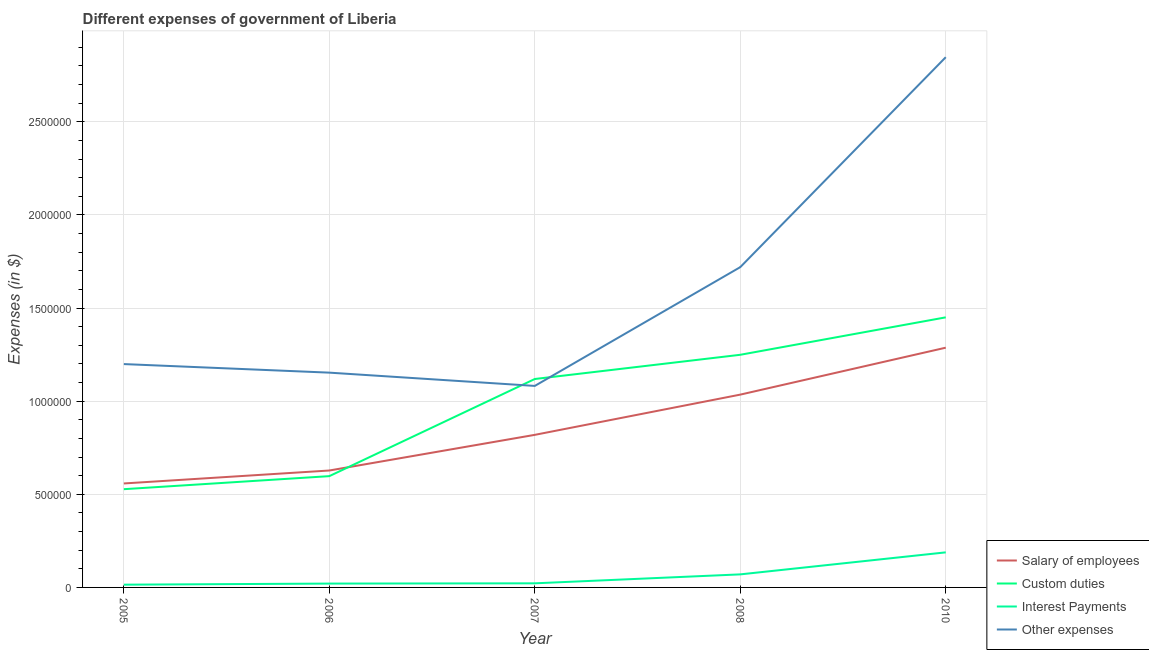Does the line corresponding to amount spent on custom duties intersect with the line corresponding to amount spent on other expenses?
Make the answer very short. Yes. Is the number of lines equal to the number of legend labels?
Offer a very short reply. Yes. What is the amount spent on interest payments in 2006?
Make the answer very short. 2.07e+04. Across all years, what is the maximum amount spent on custom duties?
Offer a very short reply. 1.45e+06. Across all years, what is the minimum amount spent on other expenses?
Offer a very short reply. 1.08e+06. In which year was the amount spent on custom duties maximum?
Make the answer very short. 2010. What is the total amount spent on interest payments in the graph?
Your answer should be compact. 3.16e+05. What is the difference between the amount spent on custom duties in 2005 and that in 2006?
Offer a terse response. -7.00e+04. What is the difference between the amount spent on salary of employees in 2006 and the amount spent on other expenses in 2005?
Give a very brief answer. -5.72e+05. What is the average amount spent on interest payments per year?
Your answer should be compact. 6.32e+04. In the year 2007, what is the difference between the amount spent on salary of employees and amount spent on custom duties?
Your answer should be very brief. -3.00e+05. In how many years, is the amount spent on other expenses greater than 1100000 $?
Provide a succinct answer. 4. What is the ratio of the amount spent on other expenses in 2005 to that in 2008?
Your response must be concise. 0.7. Is the amount spent on salary of employees in 2005 less than that in 2010?
Provide a succinct answer. Yes. Is the difference between the amount spent on salary of employees in 2005 and 2006 greater than the difference between the amount spent on interest payments in 2005 and 2006?
Ensure brevity in your answer.  No. What is the difference between the highest and the second highest amount spent on other expenses?
Make the answer very short. 1.13e+06. What is the difference between the highest and the lowest amount spent on other expenses?
Your answer should be very brief. 1.77e+06. In how many years, is the amount spent on other expenses greater than the average amount spent on other expenses taken over all years?
Make the answer very short. 2. Is the sum of the amount spent on other expenses in 2008 and 2010 greater than the maximum amount spent on salary of employees across all years?
Your answer should be very brief. Yes. Is it the case that in every year, the sum of the amount spent on other expenses and amount spent on salary of employees is greater than the sum of amount spent on interest payments and amount spent on custom duties?
Your answer should be compact. Yes. Is the amount spent on salary of employees strictly greater than the amount spent on other expenses over the years?
Offer a very short reply. No. Is the amount spent on salary of employees strictly less than the amount spent on interest payments over the years?
Your answer should be compact. No. How many lines are there?
Ensure brevity in your answer.  4. How many years are there in the graph?
Your answer should be very brief. 5. What is the difference between two consecutive major ticks on the Y-axis?
Provide a succinct answer. 5.00e+05. Does the graph contain grids?
Give a very brief answer. Yes. What is the title of the graph?
Provide a short and direct response. Different expenses of government of Liberia. What is the label or title of the Y-axis?
Your answer should be very brief. Expenses (in $). What is the Expenses (in $) in Salary of employees in 2005?
Your answer should be very brief. 5.58e+05. What is the Expenses (in $) of Custom duties in 2005?
Provide a succinct answer. 5.28e+05. What is the Expenses (in $) of Interest Payments in 2005?
Make the answer very short. 1.48e+04. What is the Expenses (in $) of Other expenses in 2005?
Ensure brevity in your answer.  1.20e+06. What is the Expenses (in $) in Salary of employees in 2006?
Offer a very short reply. 6.28e+05. What is the Expenses (in $) of Custom duties in 2006?
Provide a short and direct response. 5.98e+05. What is the Expenses (in $) in Interest Payments in 2006?
Your answer should be very brief. 2.07e+04. What is the Expenses (in $) of Other expenses in 2006?
Your answer should be compact. 1.15e+06. What is the Expenses (in $) in Salary of employees in 2007?
Your answer should be very brief. 8.19e+05. What is the Expenses (in $) in Custom duties in 2007?
Your answer should be very brief. 1.12e+06. What is the Expenses (in $) in Interest Payments in 2007?
Offer a terse response. 2.20e+04. What is the Expenses (in $) in Other expenses in 2007?
Provide a succinct answer. 1.08e+06. What is the Expenses (in $) of Salary of employees in 2008?
Your answer should be compact. 1.04e+06. What is the Expenses (in $) in Custom duties in 2008?
Make the answer very short. 1.25e+06. What is the Expenses (in $) in Interest Payments in 2008?
Provide a short and direct response. 7.01e+04. What is the Expenses (in $) of Other expenses in 2008?
Your answer should be compact. 1.72e+06. What is the Expenses (in $) in Salary of employees in 2010?
Give a very brief answer. 1.29e+06. What is the Expenses (in $) of Custom duties in 2010?
Keep it short and to the point. 1.45e+06. What is the Expenses (in $) in Interest Payments in 2010?
Give a very brief answer. 1.88e+05. What is the Expenses (in $) of Other expenses in 2010?
Provide a succinct answer. 2.85e+06. Across all years, what is the maximum Expenses (in $) in Salary of employees?
Your answer should be compact. 1.29e+06. Across all years, what is the maximum Expenses (in $) in Custom duties?
Make the answer very short. 1.45e+06. Across all years, what is the maximum Expenses (in $) of Interest Payments?
Make the answer very short. 1.88e+05. Across all years, what is the maximum Expenses (in $) in Other expenses?
Ensure brevity in your answer.  2.85e+06. Across all years, what is the minimum Expenses (in $) of Salary of employees?
Your response must be concise. 5.58e+05. Across all years, what is the minimum Expenses (in $) of Custom duties?
Your answer should be compact. 5.28e+05. Across all years, what is the minimum Expenses (in $) of Interest Payments?
Your answer should be compact. 1.48e+04. Across all years, what is the minimum Expenses (in $) in Other expenses?
Ensure brevity in your answer.  1.08e+06. What is the total Expenses (in $) in Salary of employees in the graph?
Provide a short and direct response. 4.33e+06. What is the total Expenses (in $) of Custom duties in the graph?
Give a very brief answer. 4.94e+06. What is the total Expenses (in $) in Interest Payments in the graph?
Give a very brief answer. 3.16e+05. What is the total Expenses (in $) of Other expenses in the graph?
Give a very brief answer. 8.00e+06. What is the difference between the Expenses (in $) in Salary of employees in 2005 and that in 2006?
Offer a terse response. -6.96e+04. What is the difference between the Expenses (in $) in Custom duties in 2005 and that in 2006?
Provide a succinct answer. -7.00e+04. What is the difference between the Expenses (in $) of Interest Payments in 2005 and that in 2006?
Offer a very short reply. -5850.55. What is the difference between the Expenses (in $) of Other expenses in 2005 and that in 2006?
Your answer should be compact. 4.60e+04. What is the difference between the Expenses (in $) of Salary of employees in 2005 and that in 2007?
Make the answer very short. -2.61e+05. What is the difference between the Expenses (in $) of Custom duties in 2005 and that in 2007?
Provide a succinct answer. -5.92e+05. What is the difference between the Expenses (in $) in Interest Payments in 2005 and that in 2007?
Ensure brevity in your answer.  -7224.07. What is the difference between the Expenses (in $) of Other expenses in 2005 and that in 2007?
Your response must be concise. 1.17e+05. What is the difference between the Expenses (in $) in Salary of employees in 2005 and that in 2008?
Make the answer very short. -4.77e+05. What is the difference between the Expenses (in $) of Custom duties in 2005 and that in 2008?
Provide a succinct answer. -7.22e+05. What is the difference between the Expenses (in $) of Interest Payments in 2005 and that in 2008?
Keep it short and to the point. -5.53e+04. What is the difference between the Expenses (in $) in Other expenses in 2005 and that in 2008?
Keep it short and to the point. -5.21e+05. What is the difference between the Expenses (in $) in Salary of employees in 2005 and that in 2010?
Your answer should be very brief. -7.29e+05. What is the difference between the Expenses (in $) of Custom duties in 2005 and that in 2010?
Make the answer very short. -9.23e+05. What is the difference between the Expenses (in $) in Interest Payments in 2005 and that in 2010?
Keep it short and to the point. -1.73e+05. What is the difference between the Expenses (in $) in Other expenses in 2005 and that in 2010?
Provide a short and direct response. -1.65e+06. What is the difference between the Expenses (in $) of Salary of employees in 2006 and that in 2007?
Offer a very short reply. -1.91e+05. What is the difference between the Expenses (in $) in Custom duties in 2006 and that in 2007?
Provide a short and direct response. -5.22e+05. What is the difference between the Expenses (in $) in Interest Payments in 2006 and that in 2007?
Provide a short and direct response. -1373.52. What is the difference between the Expenses (in $) in Other expenses in 2006 and that in 2007?
Keep it short and to the point. 7.13e+04. What is the difference between the Expenses (in $) in Salary of employees in 2006 and that in 2008?
Your answer should be compact. -4.08e+05. What is the difference between the Expenses (in $) of Custom duties in 2006 and that in 2008?
Your answer should be very brief. -6.52e+05. What is the difference between the Expenses (in $) of Interest Payments in 2006 and that in 2008?
Your answer should be very brief. -4.94e+04. What is the difference between the Expenses (in $) in Other expenses in 2006 and that in 2008?
Your answer should be very brief. -5.67e+05. What is the difference between the Expenses (in $) in Salary of employees in 2006 and that in 2010?
Offer a terse response. -6.60e+05. What is the difference between the Expenses (in $) in Custom duties in 2006 and that in 2010?
Your answer should be very brief. -8.53e+05. What is the difference between the Expenses (in $) in Interest Payments in 2006 and that in 2010?
Your answer should be compact. -1.68e+05. What is the difference between the Expenses (in $) in Other expenses in 2006 and that in 2010?
Your answer should be very brief. -1.69e+06. What is the difference between the Expenses (in $) in Salary of employees in 2007 and that in 2008?
Your answer should be very brief. -2.16e+05. What is the difference between the Expenses (in $) in Custom duties in 2007 and that in 2008?
Give a very brief answer. -1.30e+05. What is the difference between the Expenses (in $) in Interest Payments in 2007 and that in 2008?
Offer a very short reply. -4.80e+04. What is the difference between the Expenses (in $) in Other expenses in 2007 and that in 2008?
Ensure brevity in your answer.  -6.38e+05. What is the difference between the Expenses (in $) of Salary of employees in 2007 and that in 2010?
Offer a very short reply. -4.68e+05. What is the difference between the Expenses (in $) of Custom duties in 2007 and that in 2010?
Make the answer very short. -3.31e+05. What is the difference between the Expenses (in $) of Interest Payments in 2007 and that in 2010?
Your answer should be compact. -1.66e+05. What is the difference between the Expenses (in $) of Other expenses in 2007 and that in 2010?
Keep it short and to the point. -1.77e+06. What is the difference between the Expenses (in $) of Salary of employees in 2008 and that in 2010?
Ensure brevity in your answer.  -2.52e+05. What is the difference between the Expenses (in $) in Custom duties in 2008 and that in 2010?
Give a very brief answer. -2.01e+05. What is the difference between the Expenses (in $) of Interest Payments in 2008 and that in 2010?
Ensure brevity in your answer.  -1.18e+05. What is the difference between the Expenses (in $) of Other expenses in 2008 and that in 2010?
Provide a succinct answer. -1.13e+06. What is the difference between the Expenses (in $) in Salary of employees in 2005 and the Expenses (in $) in Custom duties in 2006?
Ensure brevity in your answer.  -3.93e+04. What is the difference between the Expenses (in $) of Salary of employees in 2005 and the Expenses (in $) of Interest Payments in 2006?
Make the answer very short. 5.38e+05. What is the difference between the Expenses (in $) in Salary of employees in 2005 and the Expenses (in $) in Other expenses in 2006?
Provide a succinct answer. -5.95e+05. What is the difference between the Expenses (in $) in Custom duties in 2005 and the Expenses (in $) in Interest Payments in 2006?
Provide a short and direct response. 5.07e+05. What is the difference between the Expenses (in $) of Custom duties in 2005 and the Expenses (in $) of Other expenses in 2006?
Provide a succinct answer. -6.26e+05. What is the difference between the Expenses (in $) in Interest Payments in 2005 and the Expenses (in $) in Other expenses in 2006?
Your answer should be compact. -1.14e+06. What is the difference between the Expenses (in $) in Salary of employees in 2005 and the Expenses (in $) in Custom duties in 2007?
Give a very brief answer. -5.61e+05. What is the difference between the Expenses (in $) in Salary of employees in 2005 and the Expenses (in $) in Interest Payments in 2007?
Offer a terse response. 5.36e+05. What is the difference between the Expenses (in $) of Salary of employees in 2005 and the Expenses (in $) of Other expenses in 2007?
Make the answer very short. -5.24e+05. What is the difference between the Expenses (in $) of Custom duties in 2005 and the Expenses (in $) of Interest Payments in 2007?
Your response must be concise. 5.05e+05. What is the difference between the Expenses (in $) of Custom duties in 2005 and the Expenses (in $) of Other expenses in 2007?
Provide a short and direct response. -5.55e+05. What is the difference between the Expenses (in $) of Interest Payments in 2005 and the Expenses (in $) of Other expenses in 2007?
Make the answer very short. -1.07e+06. What is the difference between the Expenses (in $) in Salary of employees in 2005 and the Expenses (in $) in Custom duties in 2008?
Your response must be concise. -6.91e+05. What is the difference between the Expenses (in $) in Salary of employees in 2005 and the Expenses (in $) in Interest Payments in 2008?
Your answer should be very brief. 4.88e+05. What is the difference between the Expenses (in $) in Salary of employees in 2005 and the Expenses (in $) in Other expenses in 2008?
Provide a short and direct response. -1.16e+06. What is the difference between the Expenses (in $) in Custom duties in 2005 and the Expenses (in $) in Interest Payments in 2008?
Make the answer very short. 4.57e+05. What is the difference between the Expenses (in $) of Custom duties in 2005 and the Expenses (in $) of Other expenses in 2008?
Make the answer very short. -1.19e+06. What is the difference between the Expenses (in $) in Interest Payments in 2005 and the Expenses (in $) in Other expenses in 2008?
Your response must be concise. -1.71e+06. What is the difference between the Expenses (in $) of Salary of employees in 2005 and the Expenses (in $) of Custom duties in 2010?
Provide a short and direct response. -8.92e+05. What is the difference between the Expenses (in $) of Salary of employees in 2005 and the Expenses (in $) of Interest Payments in 2010?
Ensure brevity in your answer.  3.70e+05. What is the difference between the Expenses (in $) of Salary of employees in 2005 and the Expenses (in $) of Other expenses in 2010?
Provide a short and direct response. -2.29e+06. What is the difference between the Expenses (in $) in Custom duties in 2005 and the Expenses (in $) in Interest Payments in 2010?
Your answer should be very brief. 3.39e+05. What is the difference between the Expenses (in $) in Custom duties in 2005 and the Expenses (in $) in Other expenses in 2010?
Give a very brief answer. -2.32e+06. What is the difference between the Expenses (in $) of Interest Payments in 2005 and the Expenses (in $) of Other expenses in 2010?
Make the answer very short. -2.83e+06. What is the difference between the Expenses (in $) in Salary of employees in 2006 and the Expenses (in $) in Custom duties in 2007?
Make the answer very short. -4.91e+05. What is the difference between the Expenses (in $) in Salary of employees in 2006 and the Expenses (in $) in Interest Payments in 2007?
Offer a terse response. 6.06e+05. What is the difference between the Expenses (in $) of Salary of employees in 2006 and the Expenses (in $) of Other expenses in 2007?
Offer a very short reply. -4.54e+05. What is the difference between the Expenses (in $) of Custom duties in 2006 and the Expenses (in $) of Interest Payments in 2007?
Ensure brevity in your answer.  5.76e+05. What is the difference between the Expenses (in $) of Custom duties in 2006 and the Expenses (in $) of Other expenses in 2007?
Your answer should be very brief. -4.84e+05. What is the difference between the Expenses (in $) of Interest Payments in 2006 and the Expenses (in $) of Other expenses in 2007?
Provide a short and direct response. -1.06e+06. What is the difference between the Expenses (in $) of Salary of employees in 2006 and the Expenses (in $) of Custom duties in 2008?
Give a very brief answer. -6.21e+05. What is the difference between the Expenses (in $) of Salary of employees in 2006 and the Expenses (in $) of Interest Payments in 2008?
Provide a short and direct response. 5.58e+05. What is the difference between the Expenses (in $) of Salary of employees in 2006 and the Expenses (in $) of Other expenses in 2008?
Provide a short and direct response. -1.09e+06. What is the difference between the Expenses (in $) of Custom duties in 2006 and the Expenses (in $) of Interest Payments in 2008?
Offer a very short reply. 5.28e+05. What is the difference between the Expenses (in $) in Custom duties in 2006 and the Expenses (in $) in Other expenses in 2008?
Make the answer very short. -1.12e+06. What is the difference between the Expenses (in $) in Interest Payments in 2006 and the Expenses (in $) in Other expenses in 2008?
Give a very brief answer. -1.70e+06. What is the difference between the Expenses (in $) of Salary of employees in 2006 and the Expenses (in $) of Custom duties in 2010?
Ensure brevity in your answer.  -8.22e+05. What is the difference between the Expenses (in $) of Salary of employees in 2006 and the Expenses (in $) of Interest Payments in 2010?
Keep it short and to the point. 4.40e+05. What is the difference between the Expenses (in $) in Salary of employees in 2006 and the Expenses (in $) in Other expenses in 2010?
Your response must be concise. -2.22e+06. What is the difference between the Expenses (in $) in Custom duties in 2006 and the Expenses (in $) in Interest Payments in 2010?
Your answer should be compact. 4.09e+05. What is the difference between the Expenses (in $) of Custom duties in 2006 and the Expenses (in $) of Other expenses in 2010?
Your answer should be compact. -2.25e+06. What is the difference between the Expenses (in $) in Interest Payments in 2006 and the Expenses (in $) in Other expenses in 2010?
Give a very brief answer. -2.83e+06. What is the difference between the Expenses (in $) of Salary of employees in 2007 and the Expenses (in $) of Custom duties in 2008?
Provide a succinct answer. -4.30e+05. What is the difference between the Expenses (in $) in Salary of employees in 2007 and the Expenses (in $) in Interest Payments in 2008?
Ensure brevity in your answer.  7.49e+05. What is the difference between the Expenses (in $) of Salary of employees in 2007 and the Expenses (in $) of Other expenses in 2008?
Keep it short and to the point. -9.01e+05. What is the difference between the Expenses (in $) in Custom duties in 2007 and the Expenses (in $) in Interest Payments in 2008?
Offer a very short reply. 1.05e+06. What is the difference between the Expenses (in $) in Custom duties in 2007 and the Expenses (in $) in Other expenses in 2008?
Make the answer very short. -6.01e+05. What is the difference between the Expenses (in $) of Interest Payments in 2007 and the Expenses (in $) of Other expenses in 2008?
Offer a very short reply. -1.70e+06. What is the difference between the Expenses (in $) of Salary of employees in 2007 and the Expenses (in $) of Custom duties in 2010?
Your answer should be compact. -6.31e+05. What is the difference between the Expenses (in $) of Salary of employees in 2007 and the Expenses (in $) of Interest Payments in 2010?
Ensure brevity in your answer.  6.31e+05. What is the difference between the Expenses (in $) of Salary of employees in 2007 and the Expenses (in $) of Other expenses in 2010?
Keep it short and to the point. -2.03e+06. What is the difference between the Expenses (in $) of Custom duties in 2007 and the Expenses (in $) of Interest Payments in 2010?
Offer a very short reply. 9.31e+05. What is the difference between the Expenses (in $) in Custom duties in 2007 and the Expenses (in $) in Other expenses in 2010?
Your answer should be very brief. -1.73e+06. What is the difference between the Expenses (in $) of Interest Payments in 2007 and the Expenses (in $) of Other expenses in 2010?
Keep it short and to the point. -2.83e+06. What is the difference between the Expenses (in $) in Salary of employees in 2008 and the Expenses (in $) in Custom duties in 2010?
Offer a terse response. -4.15e+05. What is the difference between the Expenses (in $) in Salary of employees in 2008 and the Expenses (in $) in Interest Payments in 2010?
Provide a short and direct response. 8.47e+05. What is the difference between the Expenses (in $) in Salary of employees in 2008 and the Expenses (in $) in Other expenses in 2010?
Your answer should be compact. -1.81e+06. What is the difference between the Expenses (in $) in Custom duties in 2008 and the Expenses (in $) in Interest Payments in 2010?
Offer a very short reply. 1.06e+06. What is the difference between the Expenses (in $) of Custom duties in 2008 and the Expenses (in $) of Other expenses in 2010?
Provide a succinct answer. -1.60e+06. What is the difference between the Expenses (in $) of Interest Payments in 2008 and the Expenses (in $) of Other expenses in 2010?
Your answer should be compact. -2.78e+06. What is the average Expenses (in $) in Salary of employees per year?
Give a very brief answer. 8.66e+05. What is the average Expenses (in $) of Custom duties per year?
Offer a very short reply. 9.89e+05. What is the average Expenses (in $) in Interest Payments per year?
Ensure brevity in your answer.  6.32e+04. What is the average Expenses (in $) of Other expenses per year?
Your answer should be very brief. 1.60e+06. In the year 2005, what is the difference between the Expenses (in $) in Salary of employees and Expenses (in $) in Custom duties?
Provide a succinct answer. 3.07e+04. In the year 2005, what is the difference between the Expenses (in $) of Salary of employees and Expenses (in $) of Interest Payments?
Provide a succinct answer. 5.43e+05. In the year 2005, what is the difference between the Expenses (in $) in Salary of employees and Expenses (in $) in Other expenses?
Your answer should be very brief. -6.41e+05. In the year 2005, what is the difference between the Expenses (in $) of Custom duties and Expenses (in $) of Interest Payments?
Your answer should be very brief. 5.13e+05. In the year 2005, what is the difference between the Expenses (in $) of Custom duties and Expenses (in $) of Other expenses?
Offer a terse response. -6.72e+05. In the year 2005, what is the difference between the Expenses (in $) of Interest Payments and Expenses (in $) of Other expenses?
Provide a succinct answer. -1.18e+06. In the year 2006, what is the difference between the Expenses (in $) in Salary of employees and Expenses (in $) in Custom duties?
Your answer should be compact. 3.02e+04. In the year 2006, what is the difference between the Expenses (in $) in Salary of employees and Expenses (in $) in Interest Payments?
Ensure brevity in your answer.  6.07e+05. In the year 2006, what is the difference between the Expenses (in $) of Salary of employees and Expenses (in $) of Other expenses?
Provide a succinct answer. -5.26e+05. In the year 2006, what is the difference between the Expenses (in $) of Custom duties and Expenses (in $) of Interest Payments?
Keep it short and to the point. 5.77e+05. In the year 2006, what is the difference between the Expenses (in $) in Custom duties and Expenses (in $) in Other expenses?
Make the answer very short. -5.56e+05. In the year 2006, what is the difference between the Expenses (in $) in Interest Payments and Expenses (in $) in Other expenses?
Keep it short and to the point. -1.13e+06. In the year 2007, what is the difference between the Expenses (in $) of Salary of employees and Expenses (in $) of Custom duties?
Your response must be concise. -3.00e+05. In the year 2007, what is the difference between the Expenses (in $) of Salary of employees and Expenses (in $) of Interest Payments?
Give a very brief answer. 7.97e+05. In the year 2007, what is the difference between the Expenses (in $) in Salary of employees and Expenses (in $) in Other expenses?
Keep it short and to the point. -2.63e+05. In the year 2007, what is the difference between the Expenses (in $) in Custom duties and Expenses (in $) in Interest Payments?
Provide a short and direct response. 1.10e+06. In the year 2007, what is the difference between the Expenses (in $) in Custom duties and Expenses (in $) in Other expenses?
Offer a very short reply. 3.71e+04. In the year 2007, what is the difference between the Expenses (in $) in Interest Payments and Expenses (in $) in Other expenses?
Keep it short and to the point. -1.06e+06. In the year 2008, what is the difference between the Expenses (in $) in Salary of employees and Expenses (in $) in Custom duties?
Make the answer very short. -2.14e+05. In the year 2008, what is the difference between the Expenses (in $) of Salary of employees and Expenses (in $) of Interest Payments?
Ensure brevity in your answer.  9.65e+05. In the year 2008, what is the difference between the Expenses (in $) of Salary of employees and Expenses (in $) of Other expenses?
Offer a terse response. -6.85e+05. In the year 2008, what is the difference between the Expenses (in $) of Custom duties and Expenses (in $) of Interest Payments?
Your answer should be compact. 1.18e+06. In the year 2008, what is the difference between the Expenses (in $) in Custom duties and Expenses (in $) in Other expenses?
Offer a very short reply. -4.71e+05. In the year 2008, what is the difference between the Expenses (in $) of Interest Payments and Expenses (in $) of Other expenses?
Your response must be concise. -1.65e+06. In the year 2010, what is the difference between the Expenses (in $) in Salary of employees and Expenses (in $) in Custom duties?
Your response must be concise. -1.63e+05. In the year 2010, what is the difference between the Expenses (in $) in Salary of employees and Expenses (in $) in Interest Payments?
Offer a very short reply. 1.10e+06. In the year 2010, what is the difference between the Expenses (in $) in Salary of employees and Expenses (in $) in Other expenses?
Give a very brief answer. -1.56e+06. In the year 2010, what is the difference between the Expenses (in $) in Custom duties and Expenses (in $) in Interest Payments?
Offer a terse response. 1.26e+06. In the year 2010, what is the difference between the Expenses (in $) in Custom duties and Expenses (in $) in Other expenses?
Keep it short and to the point. -1.40e+06. In the year 2010, what is the difference between the Expenses (in $) of Interest Payments and Expenses (in $) of Other expenses?
Provide a succinct answer. -2.66e+06. What is the ratio of the Expenses (in $) of Salary of employees in 2005 to that in 2006?
Make the answer very short. 0.89. What is the ratio of the Expenses (in $) of Custom duties in 2005 to that in 2006?
Your response must be concise. 0.88. What is the ratio of the Expenses (in $) in Interest Payments in 2005 to that in 2006?
Provide a short and direct response. 0.72. What is the ratio of the Expenses (in $) in Other expenses in 2005 to that in 2006?
Provide a succinct answer. 1.04. What is the ratio of the Expenses (in $) of Salary of employees in 2005 to that in 2007?
Provide a short and direct response. 0.68. What is the ratio of the Expenses (in $) of Custom duties in 2005 to that in 2007?
Give a very brief answer. 0.47. What is the ratio of the Expenses (in $) in Interest Payments in 2005 to that in 2007?
Keep it short and to the point. 0.67. What is the ratio of the Expenses (in $) in Other expenses in 2005 to that in 2007?
Offer a terse response. 1.11. What is the ratio of the Expenses (in $) in Salary of employees in 2005 to that in 2008?
Offer a terse response. 0.54. What is the ratio of the Expenses (in $) in Custom duties in 2005 to that in 2008?
Ensure brevity in your answer.  0.42. What is the ratio of the Expenses (in $) in Interest Payments in 2005 to that in 2008?
Make the answer very short. 0.21. What is the ratio of the Expenses (in $) in Other expenses in 2005 to that in 2008?
Make the answer very short. 0.7. What is the ratio of the Expenses (in $) of Salary of employees in 2005 to that in 2010?
Keep it short and to the point. 0.43. What is the ratio of the Expenses (in $) in Custom duties in 2005 to that in 2010?
Give a very brief answer. 0.36. What is the ratio of the Expenses (in $) of Interest Payments in 2005 to that in 2010?
Give a very brief answer. 0.08. What is the ratio of the Expenses (in $) in Other expenses in 2005 to that in 2010?
Your response must be concise. 0.42. What is the ratio of the Expenses (in $) of Salary of employees in 2006 to that in 2007?
Give a very brief answer. 0.77. What is the ratio of the Expenses (in $) in Custom duties in 2006 to that in 2007?
Your response must be concise. 0.53. What is the ratio of the Expenses (in $) in Interest Payments in 2006 to that in 2007?
Give a very brief answer. 0.94. What is the ratio of the Expenses (in $) of Other expenses in 2006 to that in 2007?
Your answer should be very brief. 1.07. What is the ratio of the Expenses (in $) in Salary of employees in 2006 to that in 2008?
Give a very brief answer. 0.61. What is the ratio of the Expenses (in $) in Custom duties in 2006 to that in 2008?
Offer a terse response. 0.48. What is the ratio of the Expenses (in $) of Interest Payments in 2006 to that in 2008?
Your response must be concise. 0.29. What is the ratio of the Expenses (in $) of Other expenses in 2006 to that in 2008?
Provide a short and direct response. 0.67. What is the ratio of the Expenses (in $) of Salary of employees in 2006 to that in 2010?
Your answer should be very brief. 0.49. What is the ratio of the Expenses (in $) in Custom duties in 2006 to that in 2010?
Provide a short and direct response. 0.41. What is the ratio of the Expenses (in $) in Interest Payments in 2006 to that in 2010?
Provide a short and direct response. 0.11. What is the ratio of the Expenses (in $) of Other expenses in 2006 to that in 2010?
Give a very brief answer. 0.41. What is the ratio of the Expenses (in $) in Salary of employees in 2007 to that in 2008?
Your answer should be compact. 0.79. What is the ratio of the Expenses (in $) in Custom duties in 2007 to that in 2008?
Keep it short and to the point. 0.9. What is the ratio of the Expenses (in $) of Interest Payments in 2007 to that in 2008?
Offer a terse response. 0.31. What is the ratio of the Expenses (in $) in Other expenses in 2007 to that in 2008?
Provide a short and direct response. 0.63. What is the ratio of the Expenses (in $) in Salary of employees in 2007 to that in 2010?
Your answer should be compact. 0.64. What is the ratio of the Expenses (in $) of Custom duties in 2007 to that in 2010?
Provide a short and direct response. 0.77. What is the ratio of the Expenses (in $) of Interest Payments in 2007 to that in 2010?
Ensure brevity in your answer.  0.12. What is the ratio of the Expenses (in $) of Other expenses in 2007 to that in 2010?
Provide a succinct answer. 0.38. What is the ratio of the Expenses (in $) in Salary of employees in 2008 to that in 2010?
Ensure brevity in your answer.  0.8. What is the ratio of the Expenses (in $) in Custom duties in 2008 to that in 2010?
Offer a terse response. 0.86. What is the ratio of the Expenses (in $) in Interest Payments in 2008 to that in 2010?
Provide a succinct answer. 0.37. What is the ratio of the Expenses (in $) of Other expenses in 2008 to that in 2010?
Make the answer very short. 0.6. What is the difference between the highest and the second highest Expenses (in $) in Salary of employees?
Offer a terse response. 2.52e+05. What is the difference between the highest and the second highest Expenses (in $) of Custom duties?
Your response must be concise. 2.01e+05. What is the difference between the highest and the second highest Expenses (in $) in Interest Payments?
Provide a short and direct response. 1.18e+05. What is the difference between the highest and the second highest Expenses (in $) of Other expenses?
Ensure brevity in your answer.  1.13e+06. What is the difference between the highest and the lowest Expenses (in $) in Salary of employees?
Give a very brief answer. 7.29e+05. What is the difference between the highest and the lowest Expenses (in $) in Custom duties?
Your answer should be very brief. 9.23e+05. What is the difference between the highest and the lowest Expenses (in $) in Interest Payments?
Your response must be concise. 1.73e+05. What is the difference between the highest and the lowest Expenses (in $) of Other expenses?
Offer a very short reply. 1.77e+06. 